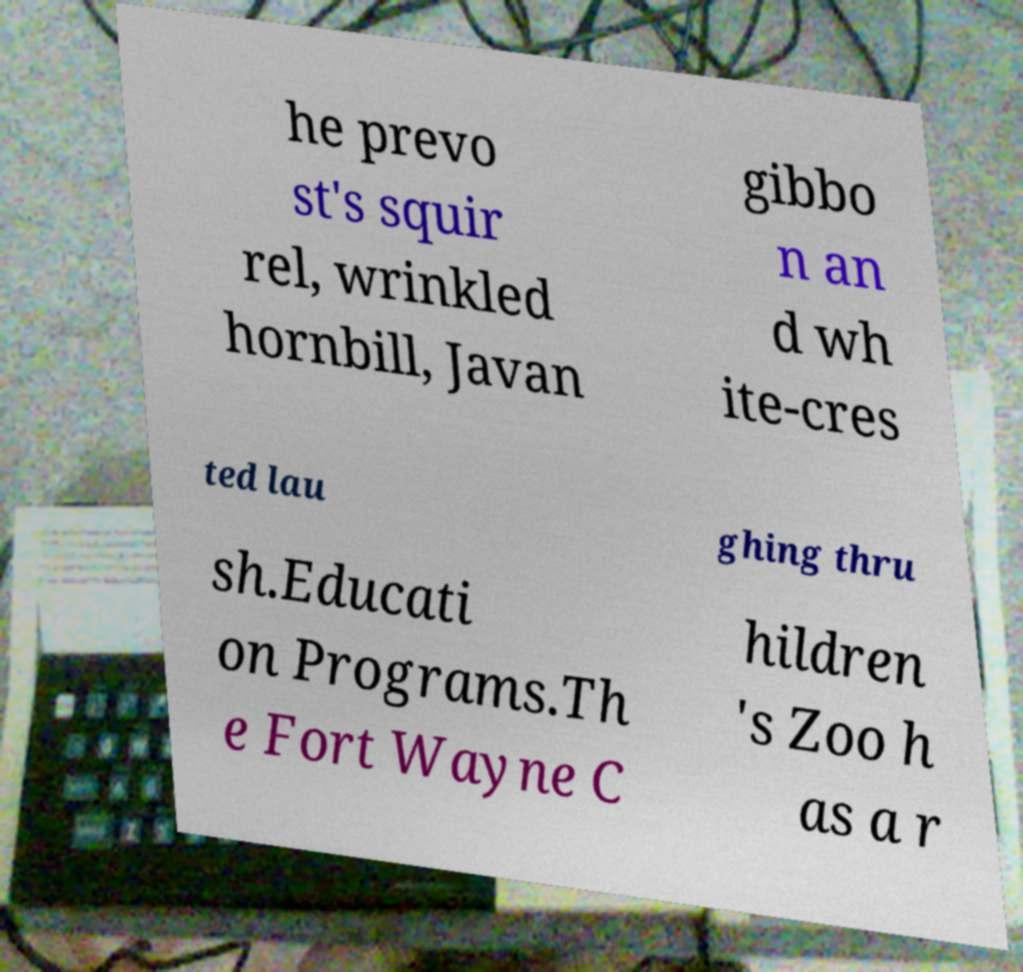Could you extract and type out the text from this image? he prevo st's squir rel, wrinkled hornbill, Javan gibbo n an d wh ite-cres ted lau ghing thru sh.Educati on Programs.Th e Fort Wayne C hildren 's Zoo h as a r 